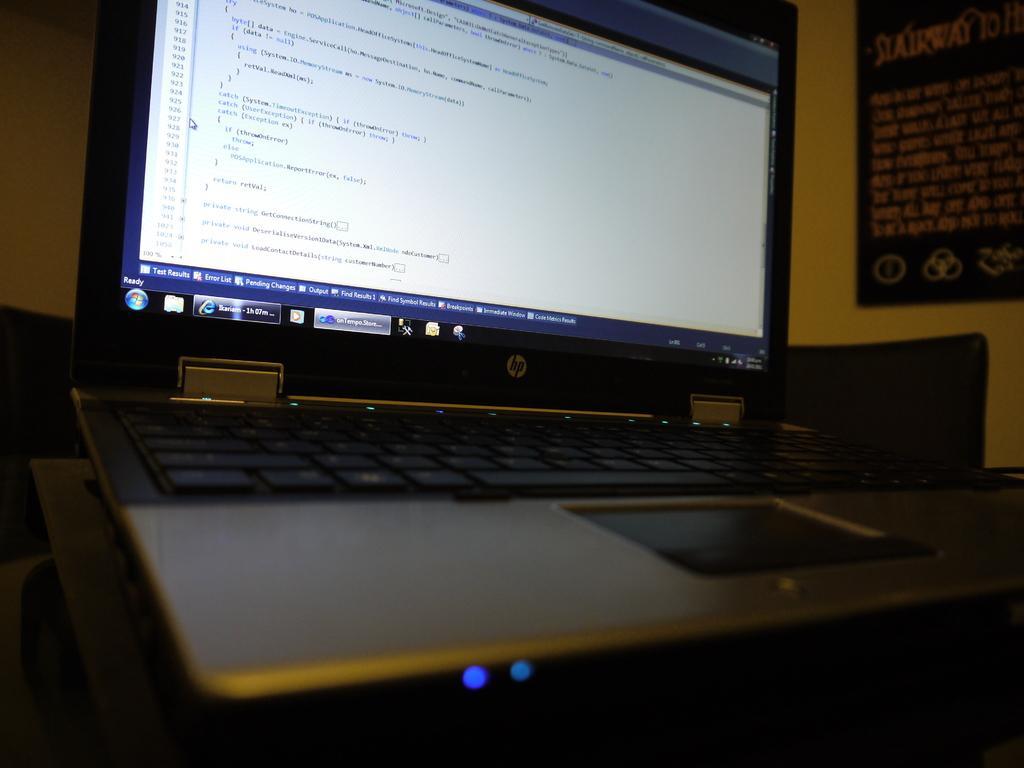Please provide a concise description of this image. In this picture we can see a close view of the laptop in the front. Behind we can see a yellow wall and a paper poster stick on it. 